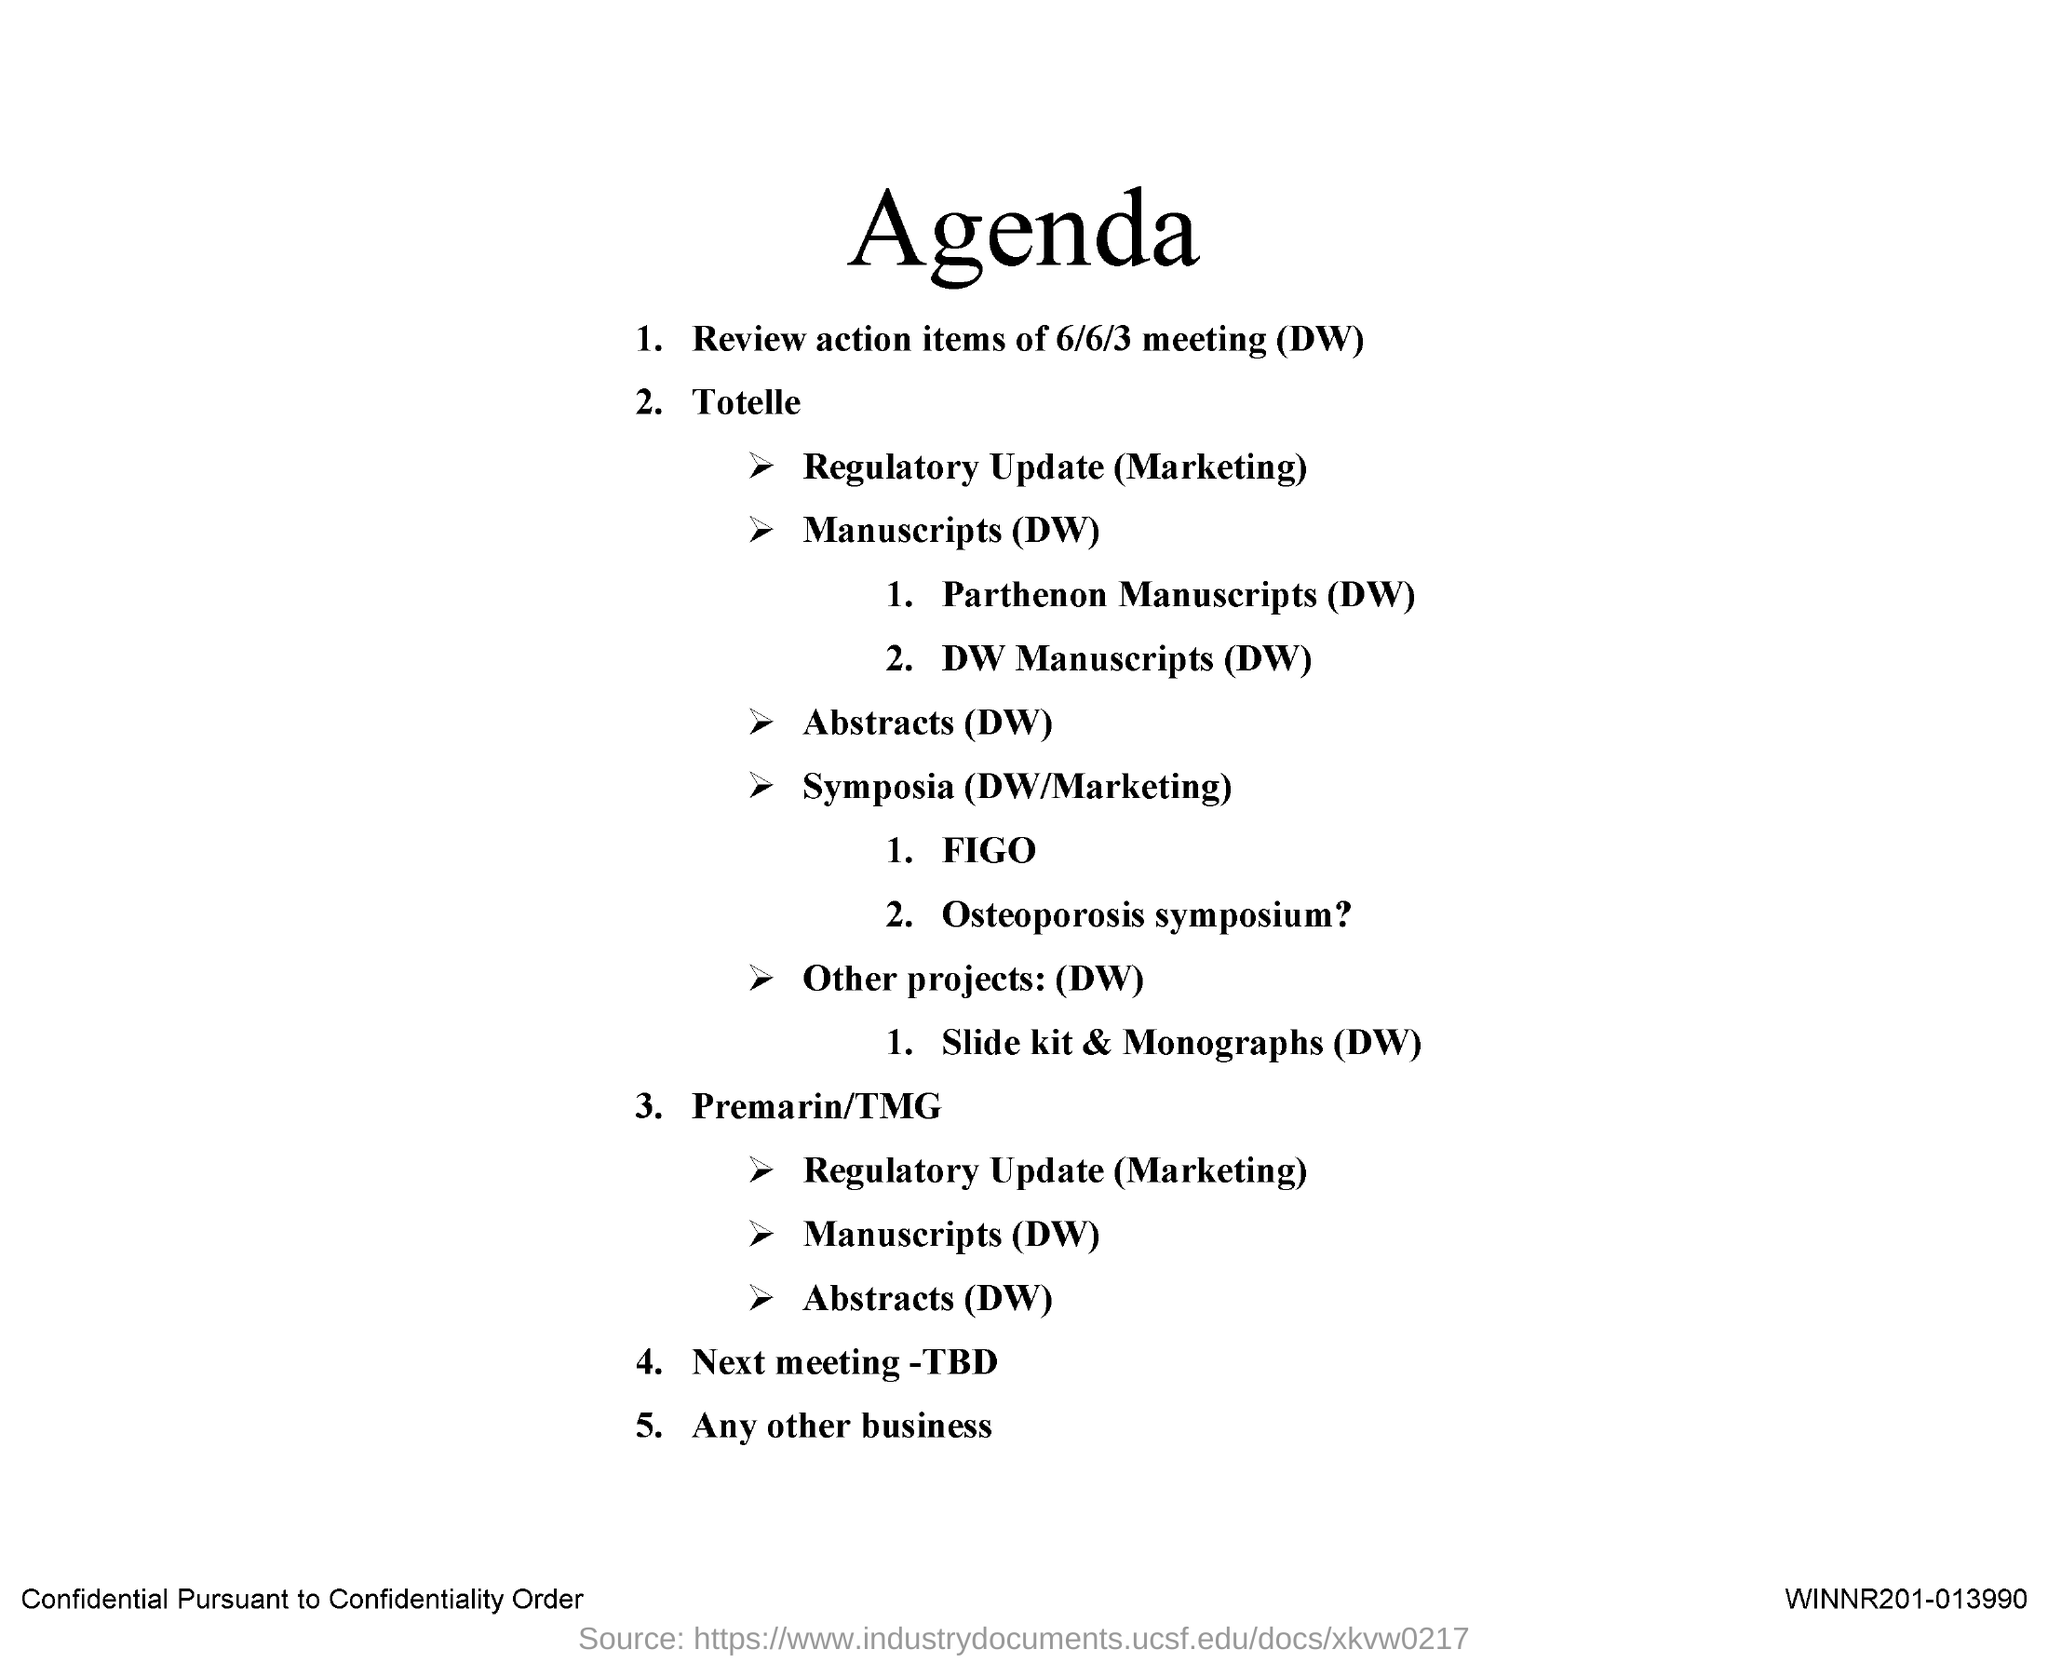Specify some key components in this picture. The action items of the meeting that took place on 6/6/3 were reviewed. The title of the document is Agenda. 